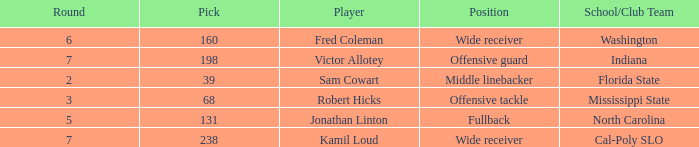Which Round has a School/Club Team of cal-poly slo, and a Pick smaller than 238? None. 